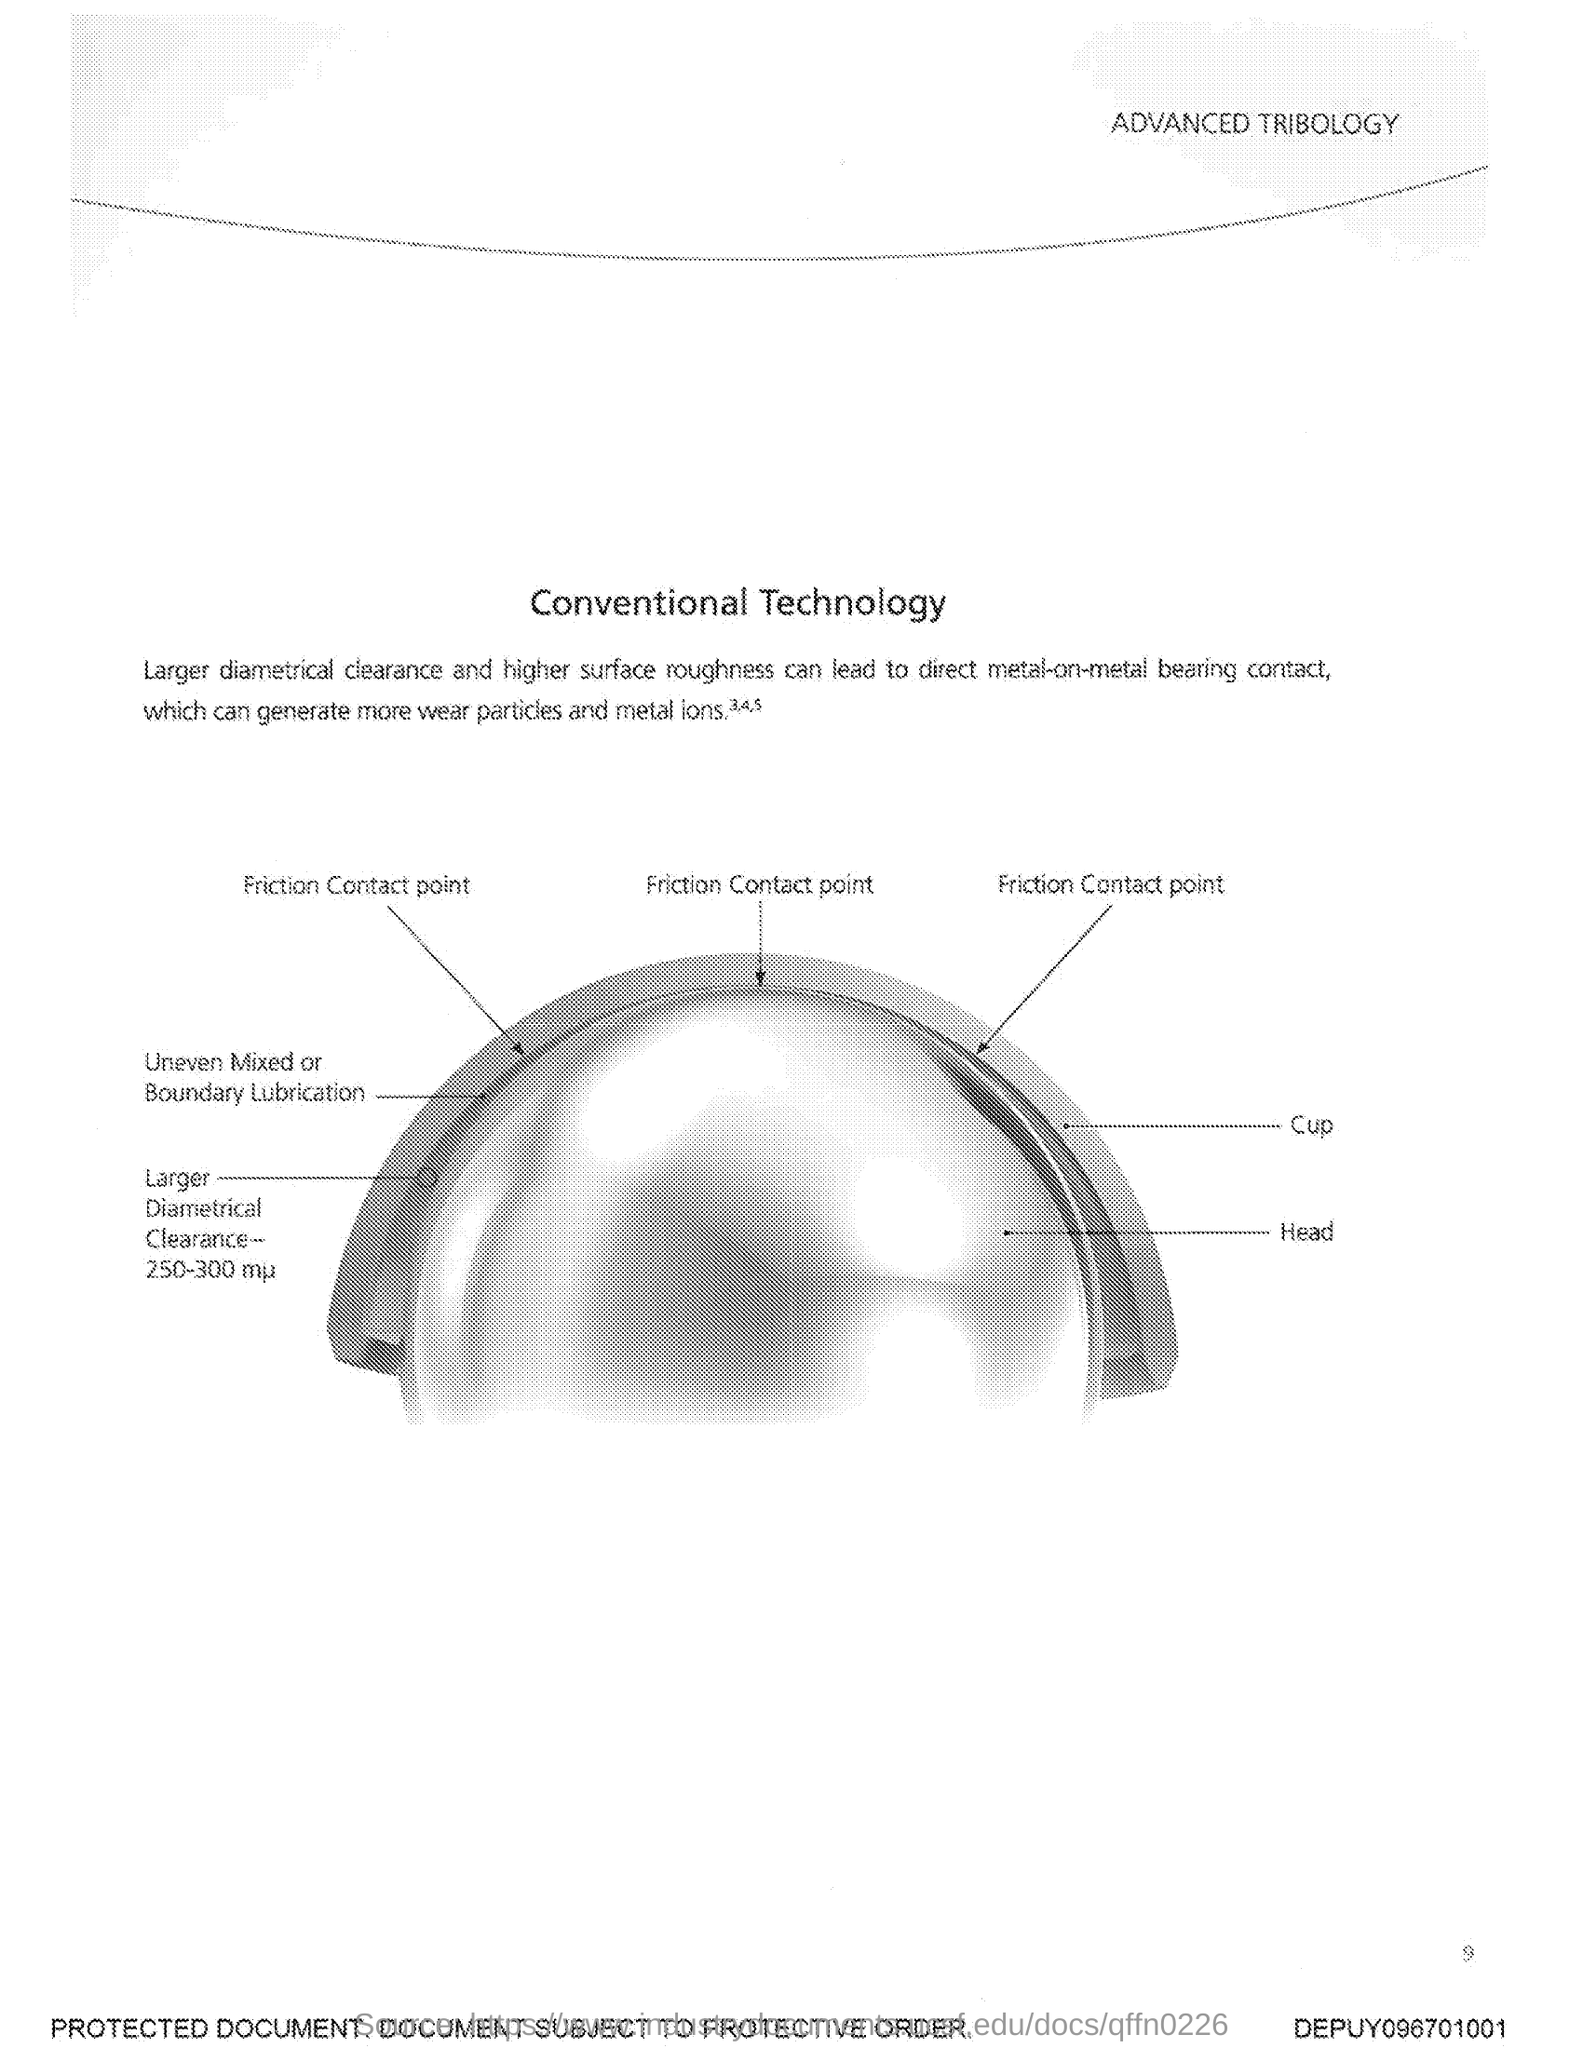Outline some significant characteristics in this image. The title of this document is 'Conventional Technology.' 